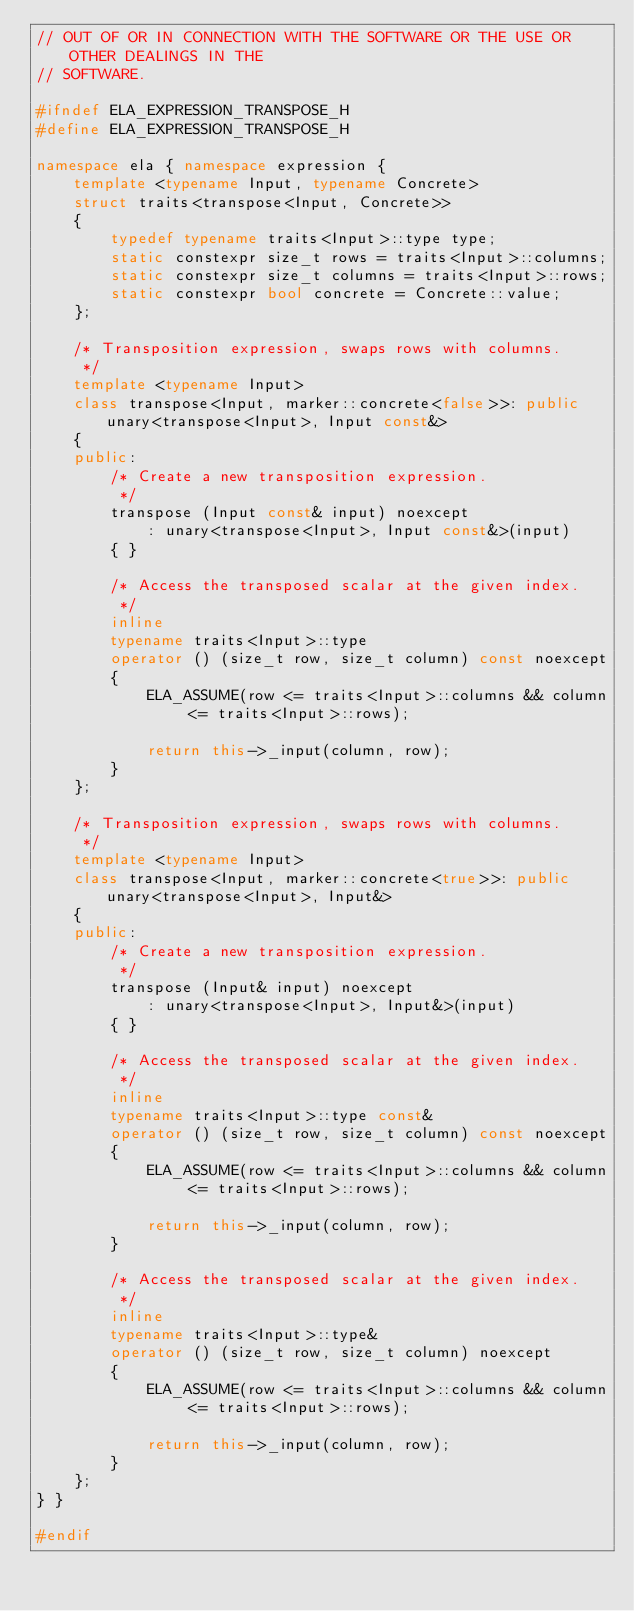<code> <loc_0><loc_0><loc_500><loc_500><_C++_>// OUT OF OR IN CONNECTION WITH THE SOFTWARE OR THE USE OR OTHER DEALINGS IN THE
// SOFTWARE.

#ifndef ELA_EXPRESSION_TRANSPOSE_H
#define ELA_EXPRESSION_TRANSPOSE_H

namespace ela { namespace expression {
	template <typename Input, typename Concrete>
	struct traits<transpose<Input, Concrete>>
	{
		typedef typename traits<Input>::type type;
		static constexpr size_t rows = traits<Input>::columns;
		static constexpr size_t columns = traits<Input>::rows;
		static constexpr bool concrete = Concrete::value;
	};

	/* Transposition expression, swaps rows with columns.
	 */
	template <typename Input>
	class transpose<Input, marker::concrete<false>>: public unary<transpose<Input>, Input const&>
	{
	public:
		/* Create a new transposition expression.
		 */
		transpose (Input const& input) noexcept
			: unary<transpose<Input>, Input const&>(input)
		{ }

		/* Access the transposed scalar at the given index.
		 */
		inline
		typename traits<Input>::type
		operator () (size_t row, size_t column) const noexcept
		{
			ELA_ASSUME(row <= traits<Input>::columns && column <= traits<Input>::rows);

			return this->_input(column, row);
		}
	};

	/* Transposition expression, swaps rows with columns.
	 */
	template <typename Input>
	class transpose<Input, marker::concrete<true>>: public unary<transpose<Input>, Input&>
	{
	public:
		/* Create a new transposition expression.
		 */
		transpose (Input& input) noexcept
			: unary<transpose<Input>, Input&>(input)
		{ }

		/* Access the transposed scalar at the given index.
		 */
		inline
		typename traits<Input>::type const&
		operator () (size_t row, size_t column) const noexcept
		{
			ELA_ASSUME(row <= traits<Input>::columns && column <= traits<Input>::rows);

			return this->_input(column, row);
		}

		/* Access the transposed scalar at the given index.
		 */
		inline
		typename traits<Input>::type&
		operator () (size_t row, size_t column) noexcept
		{
			ELA_ASSUME(row <= traits<Input>::columns && column <= traits<Input>::rows);

			return this->_input(column, row);
		}
	};
} }

#endif
</code> 